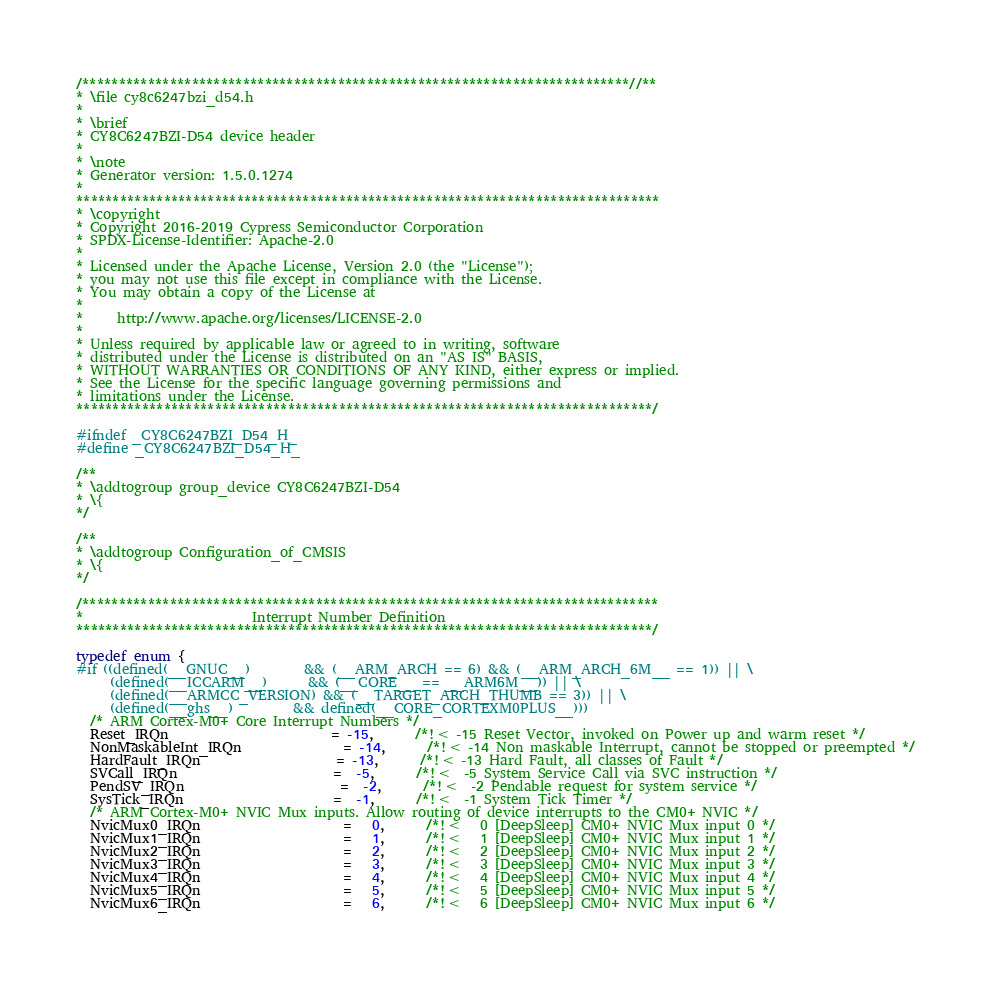Convert code to text. <code><loc_0><loc_0><loc_500><loc_500><_C_>/***************************************************************************//**
* \file cy8c6247bzi_d54.h
*
* \brief
* CY8C6247BZI-D54 device header
*
* \note
* Generator version: 1.5.0.1274
*
********************************************************************************
* \copyright
* Copyright 2016-2019 Cypress Semiconductor Corporation
* SPDX-License-Identifier: Apache-2.0
*
* Licensed under the Apache License, Version 2.0 (the "License");
* you may not use this file except in compliance with the License.
* You may obtain a copy of the License at
*
*     http://www.apache.org/licenses/LICENSE-2.0
*
* Unless required by applicable law or agreed to in writing, software
* distributed under the License is distributed on an "AS IS" BASIS,
* WITHOUT WARRANTIES OR CONDITIONS OF ANY KIND, either express or implied.
* See the License for the specific language governing permissions and
* limitations under the License.
*******************************************************************************/

#ifndef _CY8C6247BZI_D54_H_
#define _CY8C6247BZI_D54_H_

/**
* \addtogroup group_device CY8C6247BZI-D54
* \{
*/

/**
* \addtogroup Configuration_of_CMSIS
* \{
*/

/*******************************************************************************
*                         Interrupt Number Definition
*******************************************************************************/

typedef enum {
#if ((defined(__GNUC__)        && (__ARM_ARCH == 6) && (__ARM_ARCH_6M__ == 1)) || \
     (defined(__ICCARM__)      && (__CORE__ == __ARM6M__)) || \
     (defined(__ARMCC_VERSION) && (__TARGET_ARCH_THUMB == 3)) || \
     (defined(__ghs__)         && defined(__CORE_CORTEXM0PLUS__)))
  /* ARM Cortex-M0+ Core Interrupt Numbers */
  Reset_IRQn                        = -15,      /*!< -15 Reset Vector, invoked on Power up and warm reset */
  NonMaskableInt_IRQn               = -14,      /*!< -14 Non maskable Interrupt, cannot be stopped or preempted */
  HardFault_IRQn                    = -13,      /*!< -13 Hard Fault, all classes of Fault */
  SVCall_IRQn                       =  -5,      /*!<  -5 System Service Call via SVC instruction */
  PendSV_IRQn                       =  -2,      /*!<  -2 Pendable request for system service */
  SysTick_IRQn                      =  -1,      /*!<  -1 System Tick Timer */
  /* ARM Cortex-M0+ NVIC Mux inputs. Allow routing of device interrupts to the CM0+ NVIC */
  NvicMux0_IRQn                     =   0,      /*!<   0 [DeepSleep] CM0+ NVIC Mux input 0 */
  NvicMux1_IRQn                     =   1,      /*!<   1 [DeepSleep] CM0+ NVIC Mux input 1 */
  NvicMux2_IRQn                     =   2,      /*!<   2 [DeepSleep] CM0+ NVIC Mux input 2 */
  NvicMux3_IRQn                     =   3,      /*!<   3 [DeepSleep] CM0+ NVIC Mux input 3 */
  NvicMux4_IRQn                     =   4,      /*!<   4 [DeepSleep] CM0+ NVIC Mux input 4 */
  NvicMux5_IRQn                     =   5,      /*!<   5 [DeepSleep] CM0+ NVIC Mux input 5 */
  NvicMux6_IRQn                     =   6,      /*!<   6 [DeepSleep] CM0+ NVIC Mux input 6 */</code> 